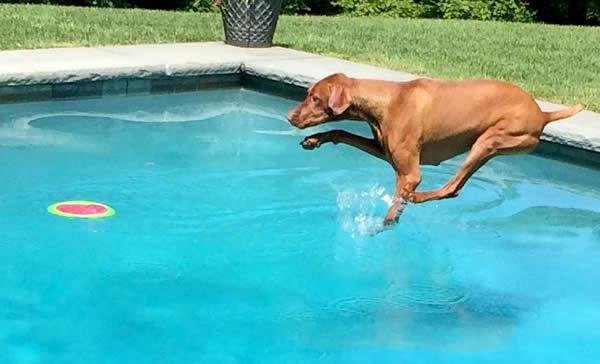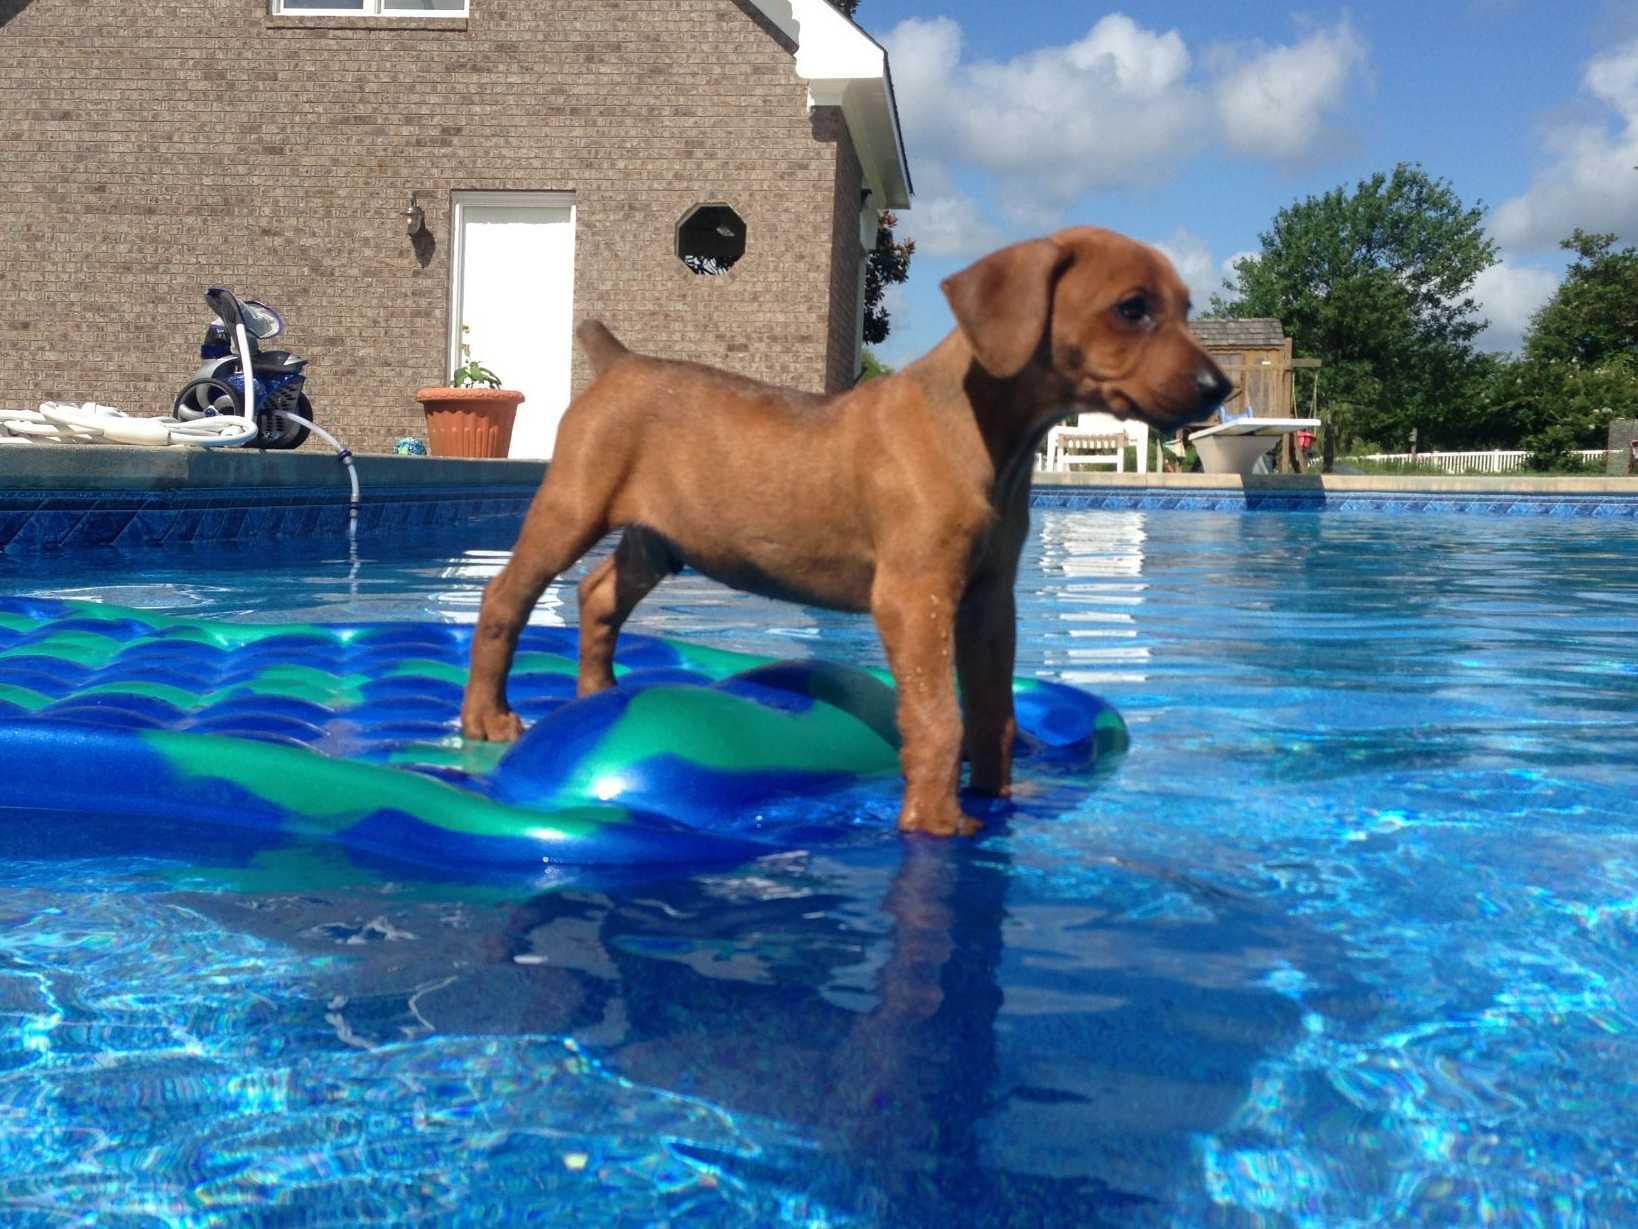The first image is the image on the left, the second image is the image on the right. Evaluate the accuracy of this statement regarding the images: "A dog is leaping into the pool". Is it true? Answer yes or no. Yes. 